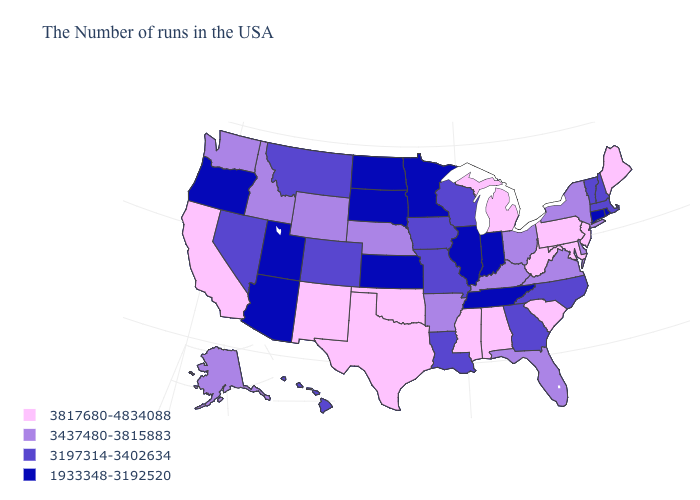How many symbols are there in the legend?
Short answer required. 4. What is the value of Ohio?
Quick response, please. 3437480-3815883. What is the highest value in the USA?
Give a very brief answer. 3817680-4834088. Name the states that have a value in the range 3437480-3815883?
Be succinct. New York, Delaware, Virginia, Ohio, Florida, Kentucky, Arkansas, Nebraska, Wyoming, Idaho, Washington, Alaska. Which states have the lowest value in the USA?
Keep it brief. Rhode Island, Connecticut, Indiana, Tennessee, Illinois, Minnesota, Kansas, South Dakota, North Dakota, Utah, Arizona, Oregon. Does New Jersey have the highest value in the USA?
Write a very short answer. Yes. What is the value of Connecticut?
Be succinct. 1933348-3192520. What is the value of Colorado?
Concise answer only. 3197314-3402634. Among the states that border Oklahoma , which have the highest value?
Quick response, please. Texas, New Mexico. What is the lowest value in the Northeast?
Short answer required. 1933348-3192520. Among the states that border Michigan , does Ohio have the highest value?
Write a very short answer. Yes. Does Kentucky have a higher value than South Carolina?
Keep it brief. No. Name the states that have a value in the range 3197314-3402634?
Concise answer only. Massachusetts, New Hampshire, Vermont, North Carolina, Georgia, Wisconsin, Louisiana, Missouri, Iowa, Colorado, Montana, Nevada, Hawaii. What is the lowest value in the USA?
Quick response, please. 1933348-3192520. Does South Dakota have a higher value than Maine?
Short answer required. No. 